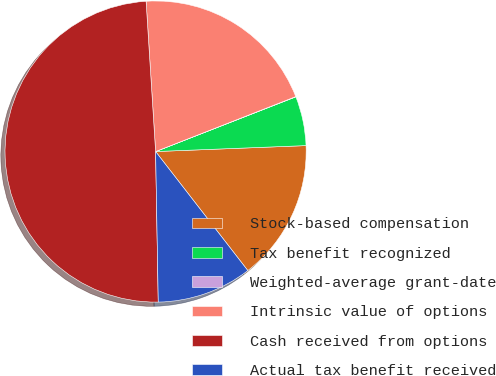<chart> <loc_0><loc_0><loc_500><loc_500><pie_chart><fcel>Stock-based compensation<fcel>Tax benefit recognized<fcel>Weighted-average grant-date<fcel>Intrinsic value of options<fcel>Cash received from options<fcel>Actual tax benefit received<nl><fcel>15.14%<fcel>5.29%<fcel>0.03%<fcel>20.06%<fcel>49.28%<fcel>10.21%<nl></chart> 